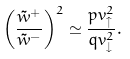Convert formula to latex. <formula><loc_0><loc_0><loc_500><loc_500>\left ( \frac { \tilde { w } ^ { + } } { \tilde { w } ^ { - } } \right ) ^ { 2 } \simeq \frac { p v _ { \uparrow } ^ { 2 } } { q v _ { \downarrow } ^ { 2 } } .</formula> 